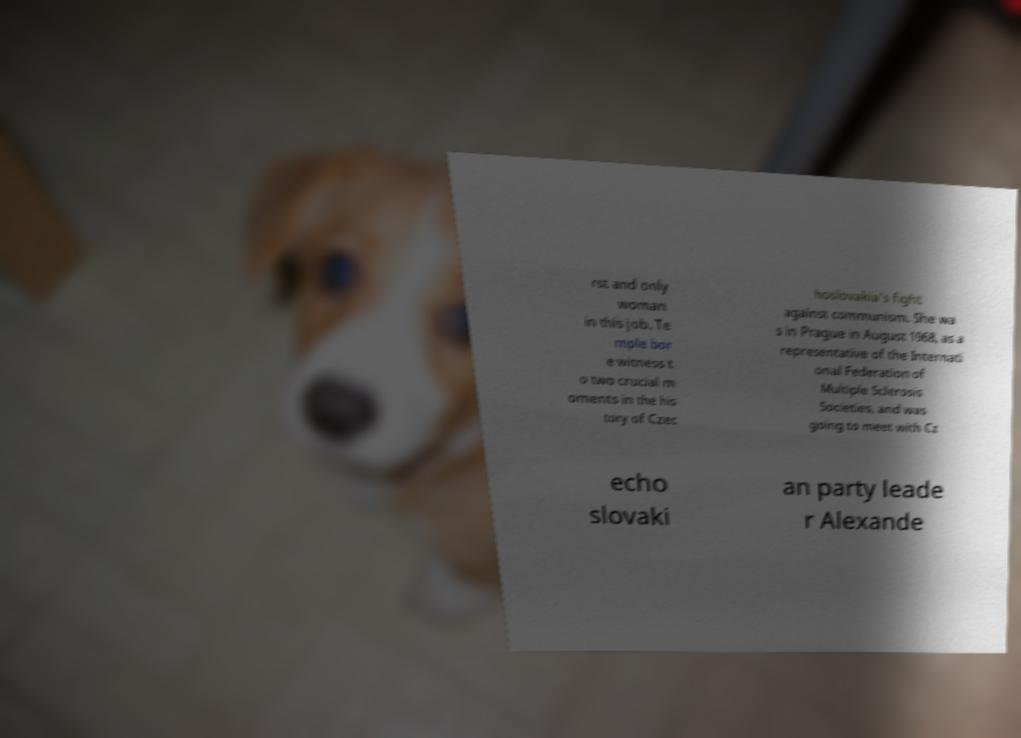Can you accurately transcribe the text from the provided image for me? rst and only woman in this job. Te mple bor e witness t o two crucial m oments in the his tory of Czec hoslovakia's fight against communism. She wa s in Prague in August 1968, as a representative of the Internati onal Federation of Multiple Sclerosis Societies, and was going to meet with Cz echo slovaki an party leade r Alexande 